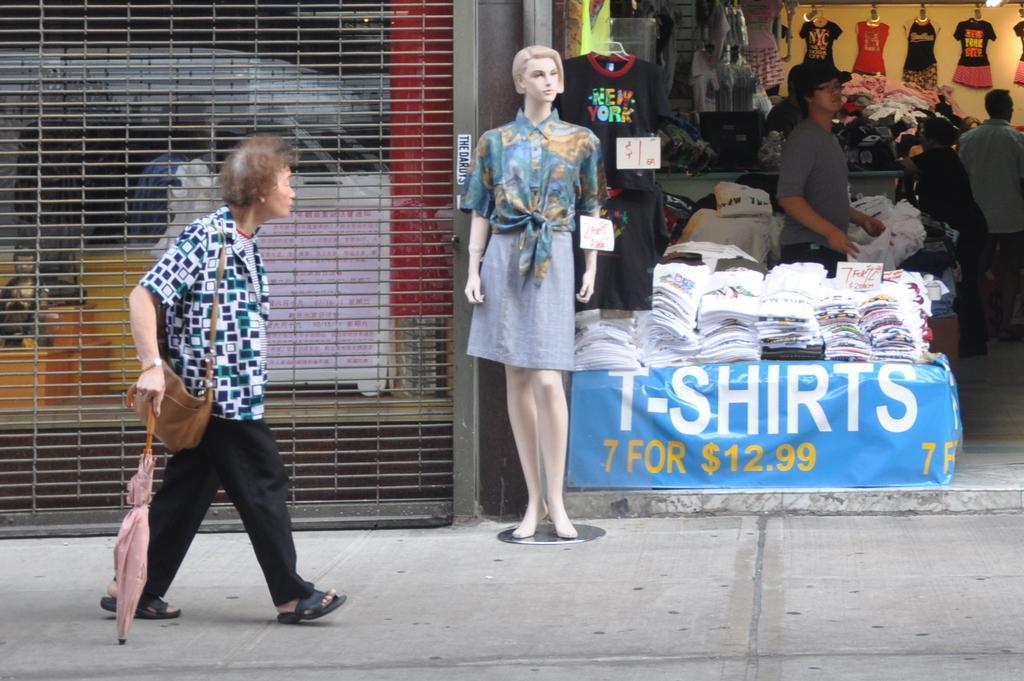Could you give a brief overview of what you see in this image? This is an outside view, in this image in the center there is one mannequin and on the right side there is a store. In that store there are some clothes and some persons are standing, and on the left side there is a shutter and through the shutter we could see some boxes and some objects. At the bottom there is a walkway. 